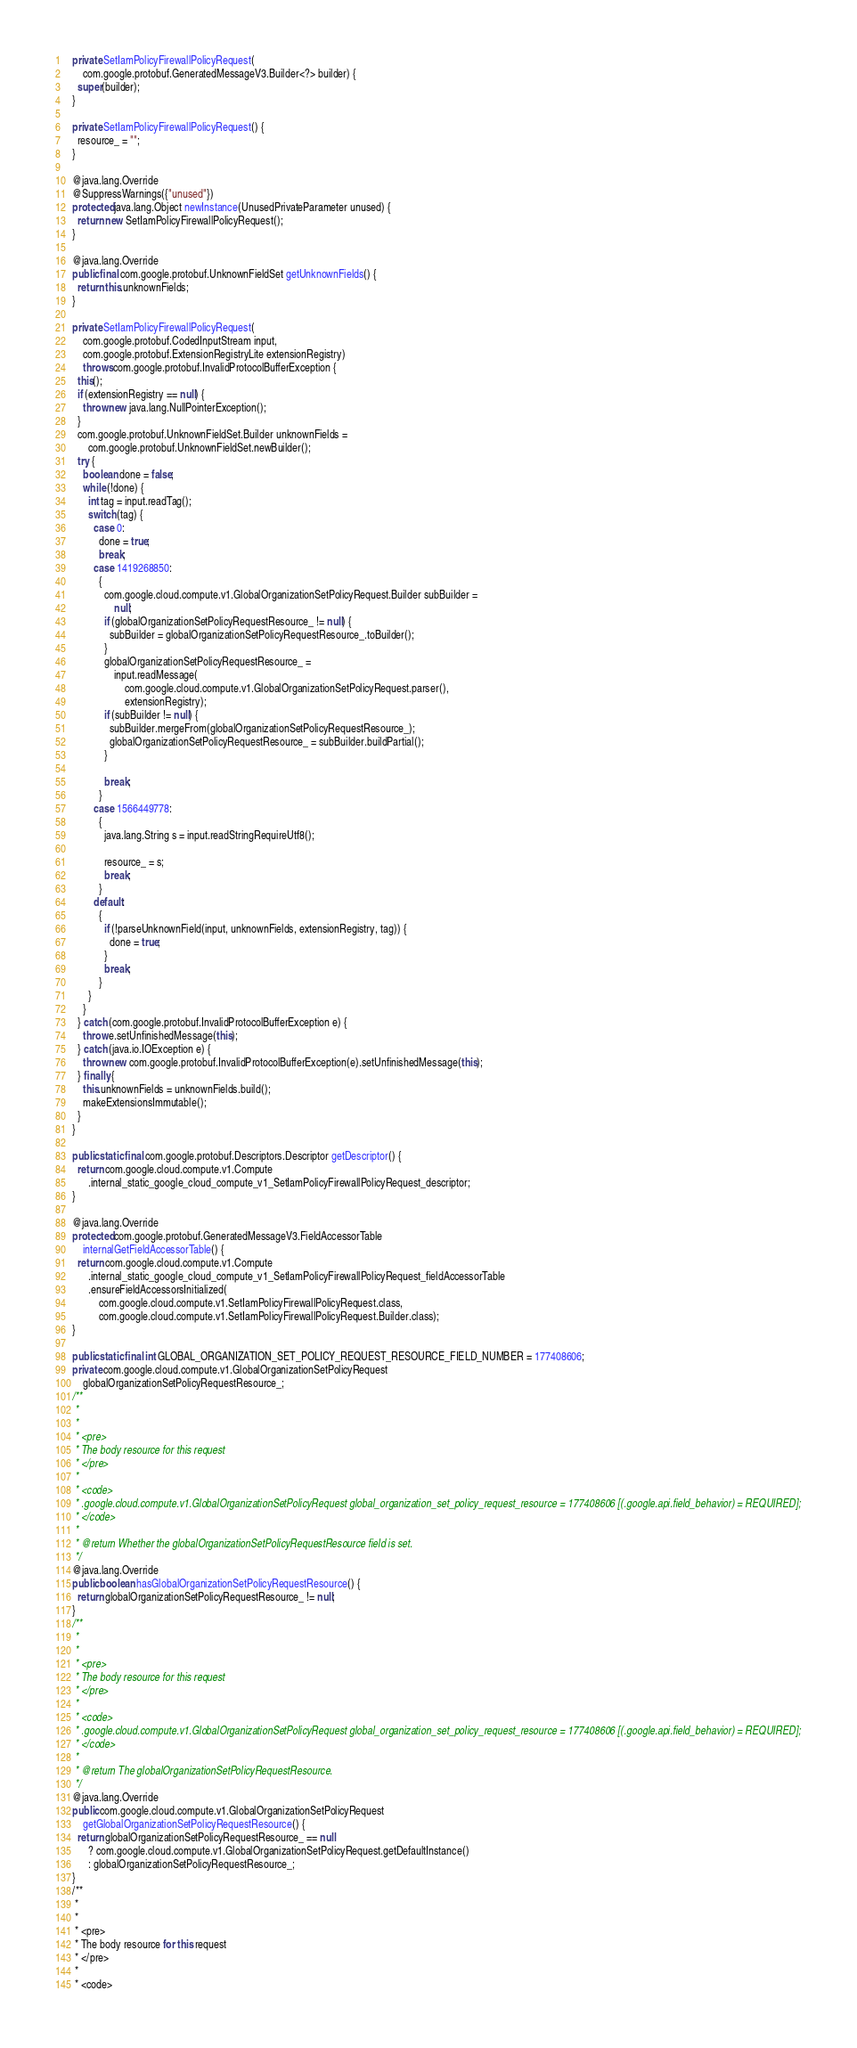Convert code to text. <code><loc_0><loc_0><loc_500><loc_500><_Java_>  private SetIamPolicyFirewallPolicyRequest(
      com.google.protobuf.GeneratedMessageV3.Builder<?> builder) {
    super(builder);
  }

  private SetIamPolicyFirewallPolicyRequest() {
    resource_ = "";
  }

  @java.lang.Override
  @SuppressWarnings({"unused"})
  protected java.lang.Object newInstance(UnusedPrivateParameter unused) {
    return new SetIamPolicyFirewallPolicyRequest();
  }

  @java.lang.Override
  public final com.google.protobuf.UnknownFieldSet getUnknownFields() {
    return this.unknownFields;
  }

  private SetIamPolicyFirewallPolicyRequest(
      com.google.protobuf.CodedInputStream input,
      com.google.protobuf.ExtensionRegistryLite extensionRegistry)
      throws com.google.protobuf.InvalidProtocolBufferException {
    this();
    if (extensionRegistry == null) {
      throw new java.lang.NullPointerException();
    }
    com.google.protobuf.UnknownFieldSet.Builder unknownFields =
        com.google.protobuf.UnknownFieldSet.newBuilder();
    try {
      boolean done = false;
      while (!done) {
        int tag = input.readTag();
        switch (tag) {
          case 0:
            done = true;
            break;
          case 1419268850:
            {
              com.google.cloud.compute.v1.GlobalOrganizationSetPolicyRequest.Builder subBuilder =
                  null;
              if (globalOrganizationSetPolicyRequestResource_ != null) {
                subBuilder = globalOrganizationSetPolicyRequestResource_.toBuilder();
              }
              globalOrganizationSetPolicyRequestResource_ =
                  input.readMessage(
                      com.google.cloud.compute.v1.GlobalOrganizationSetPolicyRequest.parser(),
                      extensionRegistry);
              if (subBuilder != null) {
                subBuilder.mergeFrom(globalOrganizationSetPolicyRequestResource_);
                globalOrganizationSetPolicyRequestResource_ = subBuilder.buildPartial();
              }

              break;
            }
          case 1566449778:
            {
              java.lang.String s = input.readStringRequireUtf8();

              resource_ = s;
              break;
            }
          default:
            {
              if (!parseUnknownField(input, unknownFields, extensionRegistry, tag)) {
                done = true;
              }
              break;
            }
        }
      }
    } catch (com.google.protobuf.InvalidProtocolBufferException e) {
      throw e.setUnfinishedMessage(this);
    } catch (java.io.IOException e) {
      throw new com.google.protobuf.InvalidProtocolBufferException(e).setUnfinishedMessage(this);
    } finally {
      this.unknownFields = unknownFields.build();
      makeExtensionsImmutable();
    }
  }

  public static final com.google.protobuf.Descriptors.Descriptor getDescriptor() {
    return com.google.cloud.compute.v1.Compute
        .internal_static_google_cloud_compute_v1_SetIamPolicyFirewallPolicyRequest_descriptor;
  }

  @java.lang.Override
  protected com.google.protobuf.GeneratedMessageV3.FieldAccessorTable
      internalGetFieldAccessorTable() {
    return com.google.cloud.compute.v1.Compute
        .internal_static_google_cloud_compute_v1_SetIamPolicyFirewallPolicyRequest_fieldAccessorTable
        .ensureFieldAccessorsInitialized(
            com.google.cloud.compute.v1.SetIamPolicyFirewallPolicyRequest.class,
            com.google.cloud.compute.v1.SetIamPolicyFirewallPolicyRequest.Builder.class);
  }

  public static final int GLOBAL_ORGANIZATION_SET_POLICY_REQUEST_RESOURCE_FIELD_NUMBER = 177408606;
  private com.google.cloud.compute.v1.GlobalOrganizationSetPolicyRequest
      globalOrganizationSetPolicyRequestResource_;
  /**
   *
   *
   * <pre>
   * The body resource for this request
   * </pre>
   *
   * <code>
   * .google.cloud.compute.v1.GlobalOrganizationSetPolicyRequest global_organization_set_policy_request_resource = 177408606 [(.google.api.field_behavior) = REQUIRED];
   * </code>
   *
   * @return Whether the globalOrganizationSetPolicyRequestResource field is set.
   */
  @java.lang.Override
  public boolean hasGlobalOrganizationSetPolicyRequestResource() {
    return globalOrganizationSetPolicyRequestResource_ != null;
  }
  /**
   *
   *
   * <pre>
   * The body resource for this request
   * </pre>
   *
   * <code>
   * .google.cloud.compute.v1.GlobalOrganizationSetPolicyRequest global_organization_set_policy_request_resource = 177408606 [(.google.api.field_behavior) = REQUIRED];
   * </code>
   *
   * @return The globalOrganizationSetPolicyRequestResource.
   */
  @java.lang.Override
  public com.google.cloud.compute.v1.GlobalOrganizationSetPolicyRequest
      getGlobalOrganizationSetPolicyRequestResource() {
    return globalOrganizationSetPolicyRequestResource_ == null
        ? com.google.cloud.compute.v1.GlobalOrganizationSetPolicyRequest.getDefaultInstance()
        : globalOrganizationSetPolicyRequestResource_;
  }
  /**
   *
   *
   * <pre>
   * The body resource for this request
   * </pre>
   *
   * <code></code> 